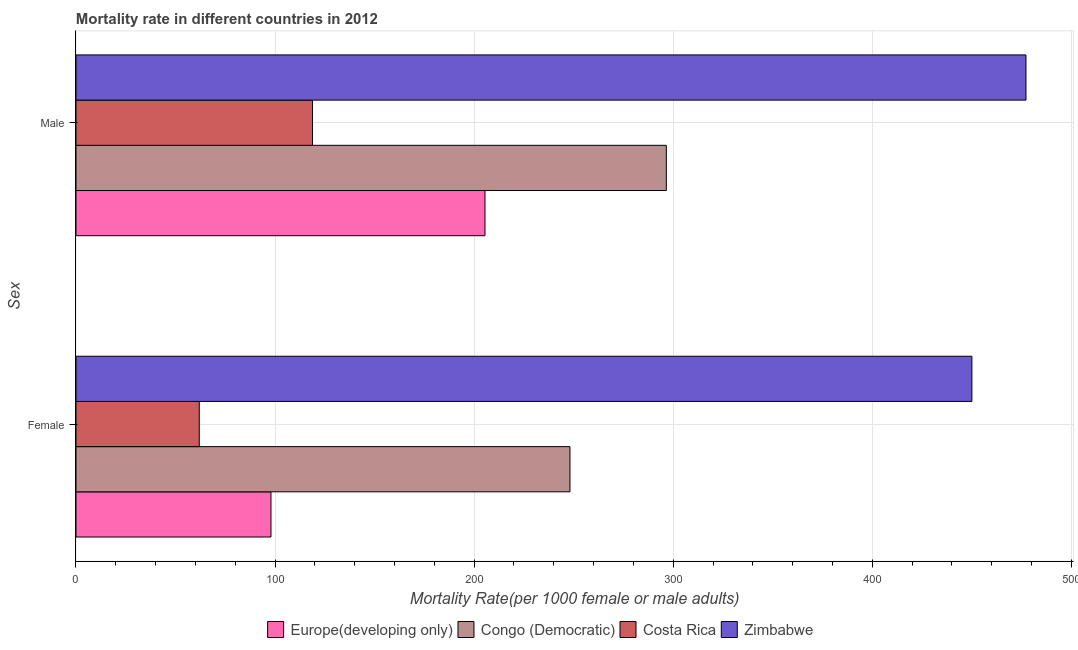How many groups of bars are there?
Ensure brevity in your answer.  2. Are the number of bars per tick equal to the number of legend labels?
Provide a succinct answer. Yes. How many bars are there on the 1st tick from the top?
Offer a very short reply. 4. How many bars are there on the 2nd tick from the bottom?
Your answer should be very brief. 4. What is the male mortality rate in Costa Rica?
Give a very brief answer. 118.81. Across all countries, what is the maximum female mortality rate?
Ensure brevity in your answer.  450.05. Across all countries, what is the minimum male mortality rate?
Provide a succinct answer. 118.81. In which country was the female mortality rate maximum?
Your response must be concise. Zimbabwe. In which country was the female mortality rate minimum?
Give a very brief answer. Costa Rica. What is the total male mortality rate in the graph?
Give a very brief answer. 1098.05. What is the difference between the female mortality rate in Zimbabwe and that in Costa Rica?
Keep it short and to the point. 388.13. What is the difference between the female mortality rate in Zimbabwe and the male mortality rate in Costa Rica?
Your response must be concise. 331.24. What is the average male mortality rate per country?
Keep it short and to the point. 274.51. What is the difference between the female mortality rate and male mortality rate in Costa Rica?
Offer a terse response. -56.89. In how many countries, is the female mortality rate greater than 380 ?
Give a very brief answer. 1. What is the ratio of the female mortality rate in Costa Rica to that in Zimbabwe?
Offer a very short reply. 0.14. What does the 4th bar from the bottom in Male represents?
Provide a short and direct response. Zimbabwe. What is the difference between two consecutive major ticks on the X-axis?
Keep it short and to the point. 100. Are the values on the major ticks of X-axis written in scientific E-notation?
Offer a very short reply. No. Does the graph contain any zero values?
Provide a short and direct response. No. How many legend labels are there?
Provide a short and direct response. 4. What is the title of the graph?
Give a very brief answer. Mortality rate in different countries in 2012. What is the label or title of the X-axis?
Provide a short and direct response. Mortality Rate(per 1000 female or male adults). What is the label or title of the Y-axis?
Your answer should be compact. Sex. What is the Mortality Rate(per 1000 female or male adults) in Europe(developing only) in Female?
Your answer should be very brief. 97.94. What is the Mortality Rate(per 1000 female or male adults) of Congo (Democratic) in Female?
Your answer should be compact. 248.14. What is the Mortality Rate(per 1000 female or male adults) of Costa Rica in Female?
Ensure brevity in your answer.  61.92. What is the Mortality Rate(per 1000 female or male adults) of Zimbabwe in Female?
Provide a short and direct response. 450.05. What is the Mortality Rate(per 1000 female or male adults) of Europe(developing only) in Male?
Provide a succinct answer. 205.46. What is the Mortality Rate(per 1000 female or male adults) in Congo (Democratic) in Male?
Your response must be concise. 296.55. What is the Mortality Rate(per 1000 female or male adults) in Costa Rica in Male?
Give a very brief answer. 118.81. What is the Mortality Rate(per 1000 female or male adults) in Zimbabwe in Male?
Give a very brief answer. 477.22. Across all Sex, what is the maximum Mortality Rate(per 1000 female or male adults) in Europe(developing only)?
Your response must be concise. 205.46. Across all Sex, what is the maximum Mortality Rate(per 1000 female or male adults) in Congo (Democratic)?
Ensure brevity in your answer.  296.55. Across all Sex, what is the maximum Mortality Rate(per 1000 female or male adults) of Costa Rica?
Offer a very short reply. 118.81. Across all Sex, what is the maximum Mortality Rate(per 1000 female or male adults) in Zimbabwe?
Offer a very short reply. 477.22. Across all Sex, what is the minimum Mortality Rate(per 1000 female or male adults) in Europe(developing only)?
Keep it short and to the point. 97.94. Across all Sex, what is the minimum Mortality Rate(per 1000 female or male adults) in Congo (Democratic)?
Ensure brevity in your answer.  248.14. Across all Sex, what is the minimum Mortality Rate(per 1000 female or male adults) of Costa Rica?
Offer a very short reply. 61.92. Across all Sex, what is the minimum Mortality Rate(per 1000 female or male adults) of Zimbabwe?
Your answer should be compact. 450.05. What is the total Mortality Rate(per 1000 female or male adults) of Europe(developing only) in the graph?
Provide a succinct answer. 303.4. What is the total Mortality Rate(per 1000 female or male adults) in Congo (Democratic) in the graph?
Your answer should be compact. 544.69. What is the total Mortality Rate(per 1000 female or male adults) of Costa Rica in the graph?
Make the answer very short. 180.74. What is the total Mortality Rate(per 1000 female or male adults) of Zimbabwe in the graph?
Provide a succinct answer. 927.27. What is the difference between the Mortality Rate(per 1000 female or male adults) in Europe(developing only) in Female and that in Male?
Your response must be concise. -107.51. What is the difference between the Mortality Rate(per 1000 female or male adults) of Congo (Democratic) in Female and that in Male?
Give a very brief answer. -48.41. What is the difference between the Mortality Rate(per 1000 female or male adults) in Costa Rica in Female and that in Male?
Provide a succinct answer. -56.89. What is the difference between the Mortality Rate(per 1000 female or male adults) in Zimbabwe in Female and that in Male?
Give a very brief answer. -27.17. What is the difference between the Mortality Rate(per 1000 female or male adults) in Europe(developing only) in Female and the Mortality Rate(per 1000 female or male adults) in Congo (Democratic) in Male?
Keep it short and to the point. -198.61. What is the difference between the Mortality Rate(per 1000 female or male adults) of Europe(developing only) in Female and the Mortality Rate(per 1000 female or male adults) of Costa Rica in Male?
Your response must be concise. -20.87. What is the difference between the Mortality Rate(per 1000 female or male adults) of Europe(developing only) in Female and the Mortality Rate(per 1000 female or male adults) of Zimbabwe in Male?
Offer a very short reply. -379.28. What is the difference between the Mortality Rate(per 1000 female or male adults) in Congo (Democratic) in Female and the Mortality Rate(per 1000 female or male adults) in Costa Rica in Male?
Give a very brief answer. 129.33. What is the difference between the Mortality Rate(per 1000 female or male adults) in Congo (Democratic) in Female and the Mortality Rate(per 1000 female or male adults) in Zimbabwe in Male?
Make the answer very short. -229.08. What is the difference between the Mortality Rate(per 1000 female or male adults) in Costa Rica in Female and the Mortality Rate(per 1000 female or male adults) in Zimbabwe in Male?
Your answer should be compact. -415.3. What is the average Mortality Rate(per 1000 female or male adults) of Europe(developing only) per Sex?
Ensure brevity in your answer.  151.7. What is the average Mortality Rate(per 1000 female or male adults) in Congo (Democratic) per Sex?
Offer a terse response. 272.35. What is the average Mortality Rate(per 1000 female or male adults) in Costa Rica per Sex?
Provide a succinct answer. 90.37. What is the average Mortality Rate(per 1000 female or male adults) of Zimbabwe per Sex?
Your answer should be very brief. 463.64. What is the difference between the Mortality Rate(per 1000 female or male adults) in Europe(developing only) and Mortality Rate(per 1000 female or male adults) in Congo (Democratic) in Female?
Make the answer very short. -150.2. What is the difference between the Mortality Rate(per 1000 female or male adults) in Europe(developing only) and Mortality Rate(per 1000 female or male adults) in Costa Rica in Female?
Keep it short and to the point. 36.02. What is the difference between the Mortality Rate(per 1000 female or male adults) in Europe(developing only) and Mortality Rate(per 1000 female or male adults) in Zimbabwe in Female?
Give a very brief answer. -352.11. What is the difference between the Mortality Rate(per 1000 female or male adults) of Congo (Democratic) and Mortality Rate(per 1000 female or male adults) of Costa Rica in Female?
Your response must be concise. 186.22. What is the difference between the Mortality Rate(per 1000 female or male adults) in Congo (Democratic) and Mortality Rate(per 1000 female or male adults) in Zimbabwe in Female?
Give a very brief answer. -201.91. What is the difference between the Mortality Rate(per 1000 female or male adults) of Costa Rica and Mortality Rate(per 1000 female or male adults) of Zimbabwe in Female?
Give a very brief answer. -388.13. What is the difference between the Mortality Rate(per 1000 female or male adults) in Europe(developing only) and Mortality Rate(per 1000 female or male adults) in Congo (Democratic) in Male?
Provide a short and direct response. -91.1. What is the difference between the Mortality Rate(per 1000 female or male adults) in Europe(developing only) and Mortality Rate(per 1000 female or male adults) in Costa Rica in Male?
Make the answer very short. 86.64. What is the difference between the Mortality Rate(per 1000 female or male adults) in Europe(developing only) and Mortality Rate(per 1000 female or male adults) in Zimbabwe in Male?
Your response must be concise. -271.77. What is the difference between the Mortality Rate(per 1000 female or male adults) of Congo (Democratic) and Mortality Rate(per 1000 female or male adults) of Costa Rica in Male?
Ensure brevity in your answer.  177.74. What is the difference between the Mortality Rate(per 1000 female or male adults) in Congo (Democratic) and Mortality Rate(per 1000 female or male adults) in Zimbabwe in Male?
Offer a terse response. -180.67. What is the difference between the Mortality Rate(per 1000 female or male adults) in Costa Rica and Mortality Rate(per 1000 female or male adults) in Zimbabwe in Male?
Keep it short and to the point. -358.41. What is the ratio of the Mortality Rate(per 1000 female or male adults) in Europe(developing only) in Female to that in Male?
Offer a very short reply. 0.48. What is the ratio of the Mortality Rate(per 1000 female or male adults) of Congo (Democratic) in Female to that in Male?
Offer a terse response. 0.84. What is the ratio of the Mortality Rate(per 1000 female or male adults) of Costa Rica in Female to that in Male?
Ensure brevity in your answer.  0.52. What is the ratio of the Mortality Rate(per 1000 female or male adults) of Zimbabwe in Female to that in Male?
Offer a very short reply. 0.94. What is the difference between the highest and the second highest Mortality Rate(per 1000 female or male adults) in Europe(developing only)?
Offer a terse response. 107.51. What is the difference between the highest and the second highest Mortality Rate(per 1000 female or male adults) in Congo (Democratic)?
Provide a short and direct response. 48.41. What is the difference between the highest and the second highest Mortality Rate(per 1000 female or male adults) of Costa Rica?
Ensure brevity in your answer.  56.89. What is the difference between the highest and the second highest Mortality Rate(per 1000 female or male adults) in Zimbabwe?
Offer a very short reply. 27.17. What is the difference between the highest and the lowest Mortality Rate(per 1000 female or male adults) in Europe(developing only)?
Your answer should be compact. 107.51. What is the difference between the highest and the lowest Mortality Rate(per 1000 female or male adults) in Congo (Democratic)?
Offer a very short reply. 48.41. What is the difference between the highest and the lowest Mortality Rate(per 1000 female or male adults) in Costa Rica?
Your answer should be compact. 56.89. What is the difference between the highest and the lowest Mortality Rate(per 1000 female or male adults) of Zimbabwe?
Offer a terse response. 27.17. 